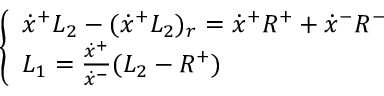Convert formula to latex. <formula><loc_0><loc_0><loc_500><loc_500>\left \{ \begin{array} { l } { { \dot { x } ^ { + } L _ { 2 } - ( \dot { x } ^ { + } L _ { 2 } ) _ { r } = \dot { x } ^ { + } R ^ { + } + \dot { x } ^ { - } R ^ { - } } } \\ { { L _ { 1 } = { \frac { \dot { x } ^ { + } } { \dot { x } ^ { - } } } ( L _ { 2 } - R ^ { + } ) } } \end{array}</formula> 